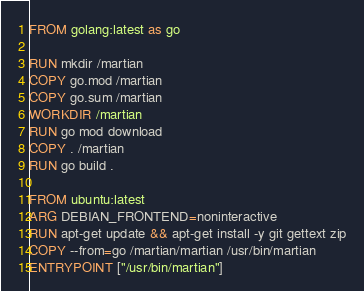Convert code to text. <code><loc_0><loc_0><loc_500><loc_500><_Dockerfile_>FROM golang:latest as go

RUN mkdir /martian
COPY go.mod /martian
COPY go.sum /martian
WORKDIR /martian
RUN go mod download
COPY . /martian
RUN go build .

FROM ubuntu:latest
ARG DEBIAN_FRONTEND=noninteractive
RUN apt-get update && apt-get install -y git gettext zip
COPY --from=go /martian/martian /usr/bin/martian
ENTRYPOINT ["/usr/bin/martian"]
</code> 